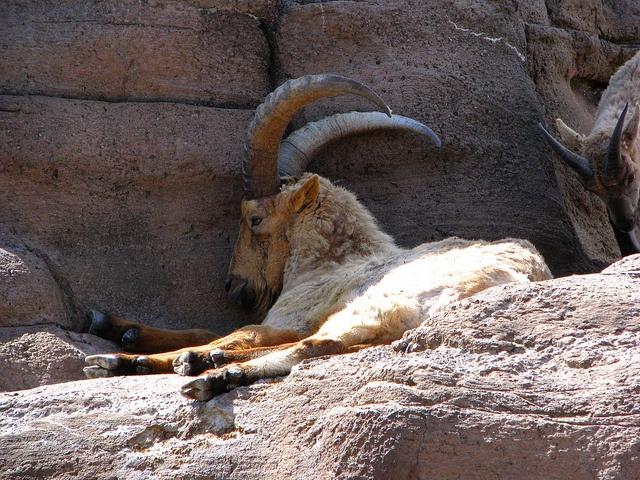Describe the objects in this image and their specific colors. I can see sheep in black, gray, white, and maroon tones and sheep in black and gray tones in this image. 